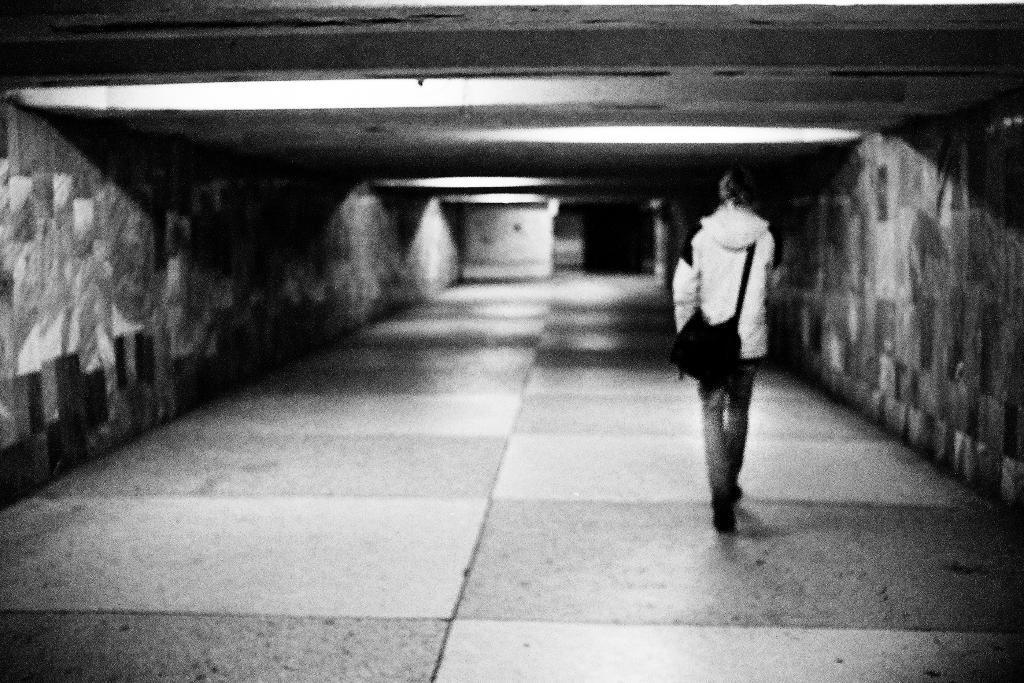In one or two sentences, can you explain what this image depicts? In this image I can see on the right side a person is walking, he is wearing trouser, sweater and a bag. 